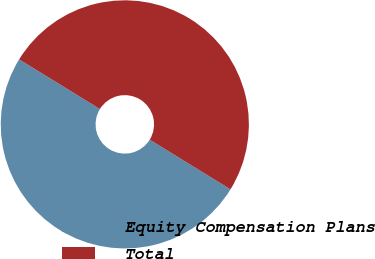<chart> <loc_0><loc_0><loc_500><loc_500><pie_chart><fcel>Equity Compensation Plans<fcel>Total<nl><fcel>50.0%<fcel>50.0%<nl></chart> 